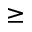Convert formula to latex. <formula><loc_0><loc_0><loc_500><loc_500>\geq</formula> 